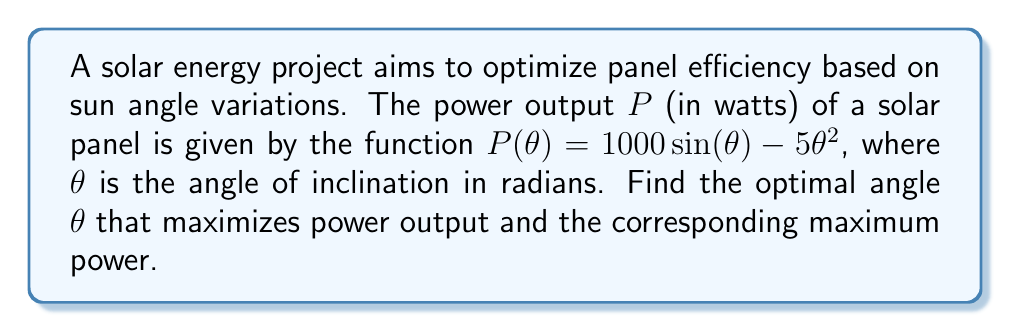Show me your answer to this math problem. To find the optimal angle that maximizes power output, we need to find the maximum of the function $P(θ) = 1000 \sin(θ) - 5θ^2$. This can be done by finding where the derivative of $P(θ)$ equals zero.

Step 1: Calculate the derivative of $P(θ)$.
$$P'(θ) = 1000 \cos(θ) - 10θ$$

Step 2: Set the derivative equal to zero and solve for $θ$.
$$1000 \cos(θ) - 10θ = 0$$
$$\cos(θ) = \frac{θ}{100}$$

This equation cannot be solved algebraically, so we need to use numerical methods or graphical approach to find the solution. Using a graphing calculator or computer software, we can find that the solution is approximately:

$$θ ≈ 0.5611 \text{ radians} ≈ 32.15°$$

Step 3: Verify this is a maximum by checking the second derivative is negative at this point.
$$P''(θ) = -1000 \sin(θ) - 10$$
At $θ ≈ 0.5611$, $P''(θ) < 0$, confirming a maximum.

Step 4: Calculate the maximum power output by substituting the optimal angle into the original function.
$$P(0.5611) = 1000 \sin(0.5611) - 5(0.5611)^2 ≈ 530.5 \text{ watts}$$
Answer: Optimal angle: $0.5611$ radians ($32.15°$); Maximum power: $530.5$ watts 